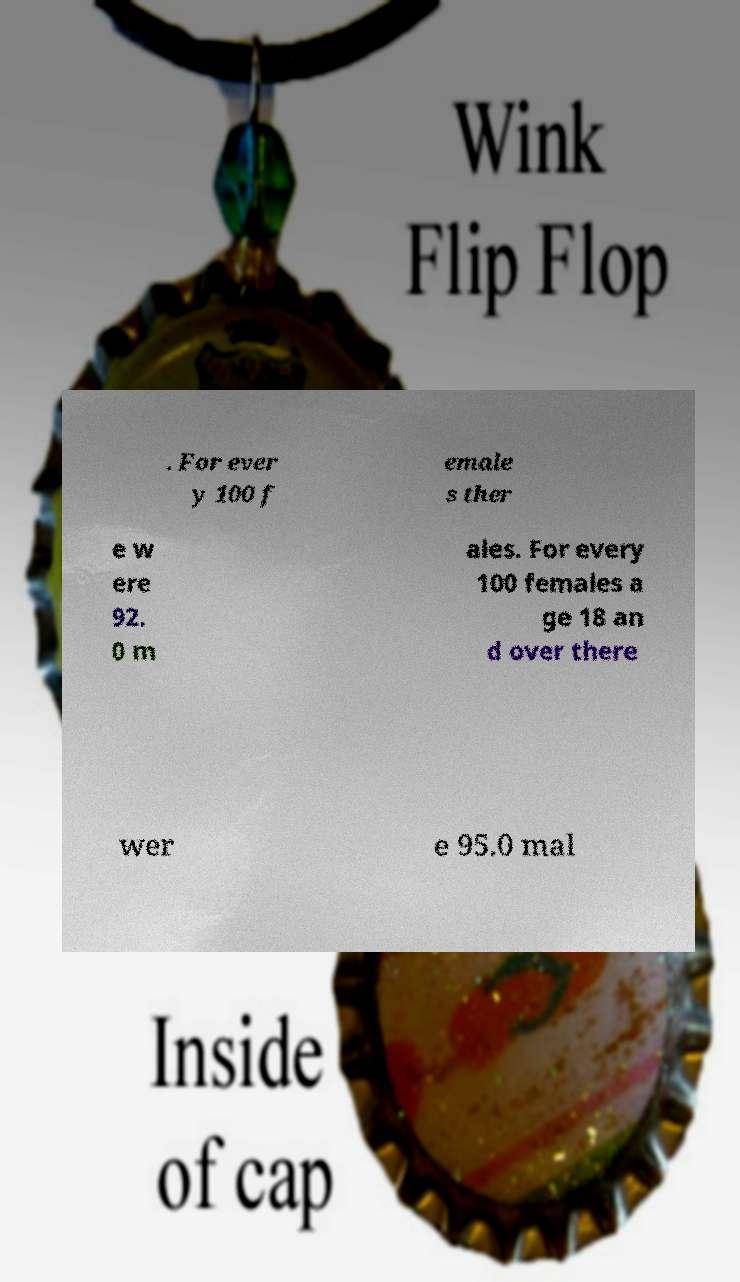What messages or text are displayed in this image? I need them in a readable, typed format. . For ever y 100 f emale s ther e w ere 92. 0 m ales. For every 100 females a ge 18 an d over there wer e 95.0 mal 